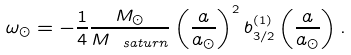Convert formula to latex. <formula><loc_0><loc_0><loc_500><loc_500>\omega _ { \odot } = - \frac { 1 } { 4 } \frac { M _ { \odot } } { M _ { \ s a t u r n } } \left ( \frac { a } { a _ { \odot } } \right ) ^ { 2 } b _ { 3 / 2 } ^ { ( 1 ) } \left ( \frac { a } { a _ { \odot } } \right ) .</formula> 